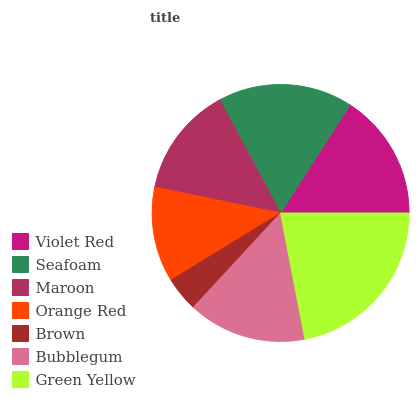Is Brown the minimum?
Answer yes or no. Yes. Is Green Yellow the maximum?
Answer yes or no. Yes. Is Seafoam the minimum?
Answer yes or no. No. Is Seafoam the maximum?
Answer yes or no. No. Is Seafoam greater than Violet Red?
Answer yes or no. Yes. Is Violet Red less than Seafoam?
Answer yes or no. Yes. Is Violet Red greater than Seafoam?
Answer yes or no. No. Is Seafoam less than Violet Red?
Answer yes or no. No. Is Bubblegum the high median?
Answer yes or no. Yes. Is Bubblegum the low median?
Answer yes or no. Yes. Is Maroon the high median?
Answer yes or no. No. Is Green Yellow the low median?
Answer yes or no. No. 